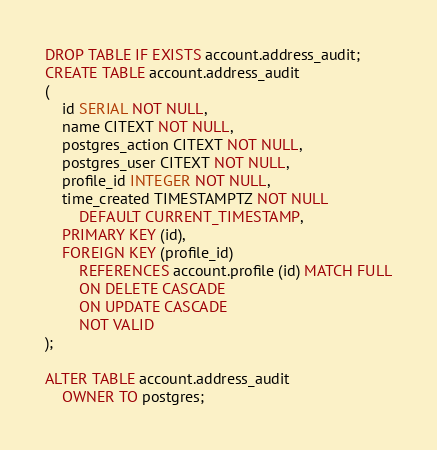Convert code to text. <code><loc_0><loc_0><loc_500><loc_500><_SQL_>DROP TABLE IF EXISTS account.address_audit;
CREATE TABLE account.address_audit
(
    id SERIAL NOT NULL,
    name CITEXT NOT NULL,
    postgres_action CITEXT NOT NULL,
    postgres_user CITEXT NOT NULL,
    profile_id INTEGER NOT NULL,
    time_created TIMESTAMPTZ NOT NULL
        DEFAULT CURRENT_TIMESTAMP,
    PRIMARY KEY (id),
    FOREIGN KEY (profile_id)
        REFERENCES account.profile (id) MATCH FULL
        ON DELETE CASCADE
        ON UPDATE CASCADE
        NOT VALID
);

ALTER TABLE account.address_audit
    OWNER TO postgres;
</code> 